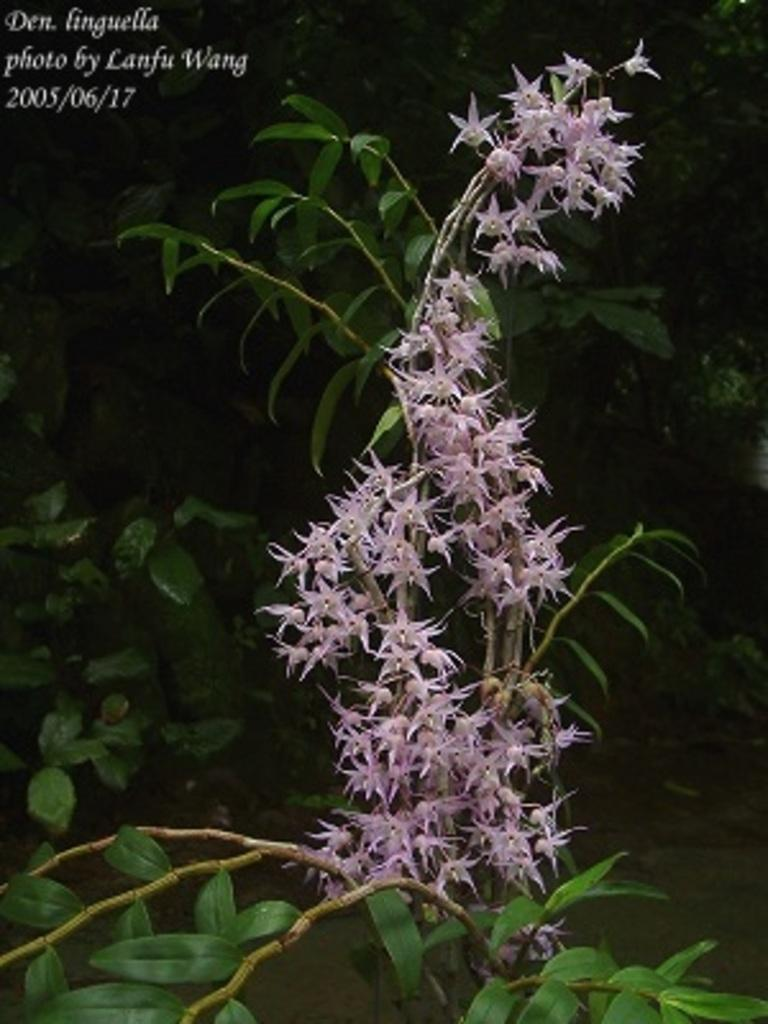What type of living organisms can be seen in the image? Plants can be seen in the image. What color are the flowers on the plants? There are pink flowers in the image. Where is the text or writing located in the image? The text or writing is on the left side top of the image. How many birds are sitting on the basket in the image? There is no basket or birds present in the image. 